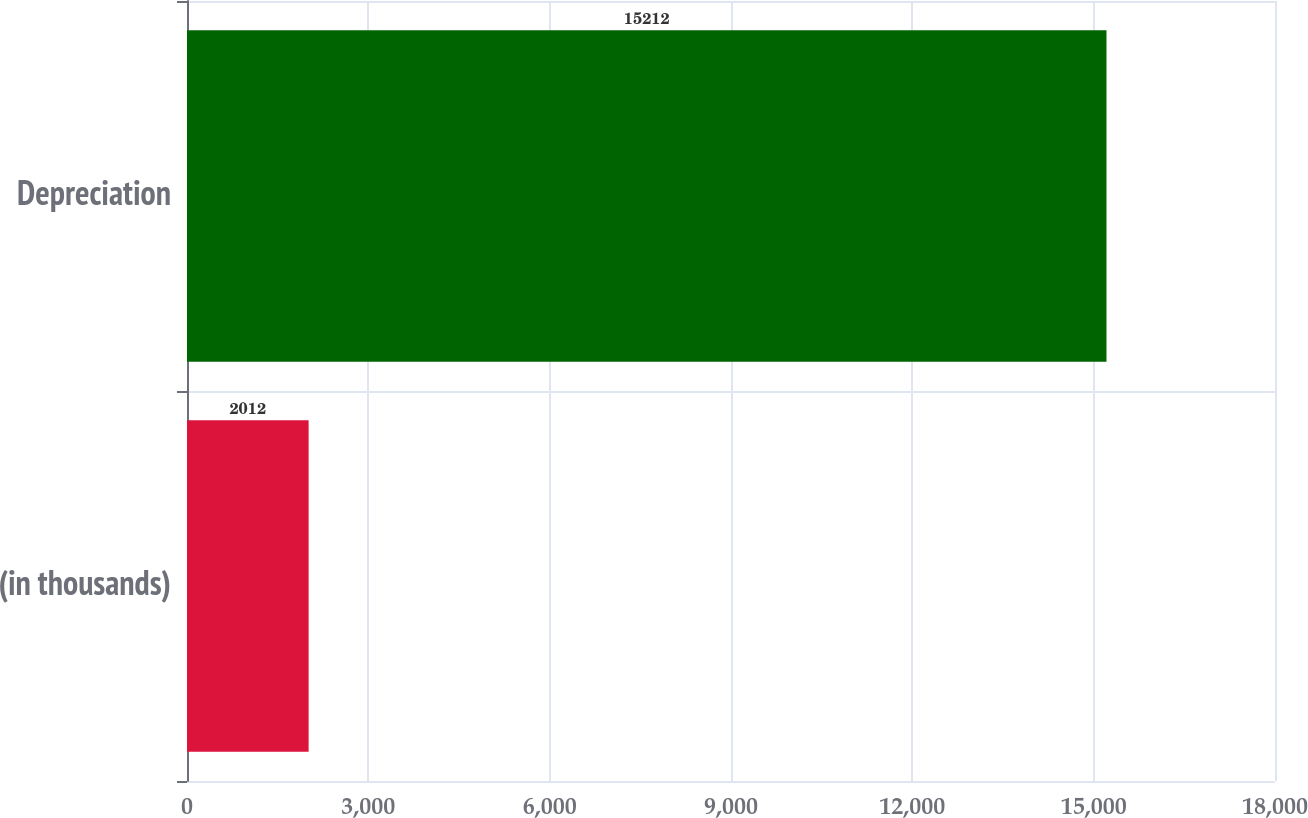Convert chart to OTSL. <chart><loc_0><loc_0><loc_500><loc_500><bar_chart><fcel>(in thousands)<fcel>Depreciation<nl><fcel>2012<fcel>15212<nl></chart> 